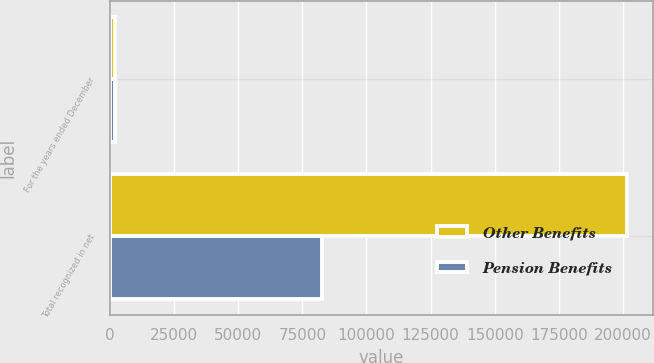Convert chart. <chart><loc_0><loc_0><loc_500><loc_500><stacked_bar_chart><ecel><fcel>For the years ended December<fcel>Total recognized in net<nl><fcel>Other Benefits<fcel>2006<fcel>201502<nl><fcel>Pension Benefits<fcel>2006<fcel>82702<nl></chart> 